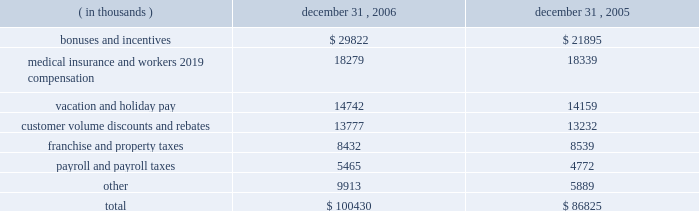Packaging corporation of america notes to consolidated financial statements ( continued ) december 31 , 2006 4 .
Stock-based compensation ( continued ) as of december 31 , 2006 , there was $ 8330000 of total unrecognized compensation costs related to the restricted stock awards .
The company expects to recognize the cost of these stock awards over a weighted-average period of 2.5 years .
Accrued liabilities the components of accrued liabilities are as follows: .
Employee benefit plans and other postretirement benefits in connection with the acquisition from pactiv , pca and pactiv entered into a human resources agreement which , among other items , granted pca employees continued participation in the pactiv pension plan for a period of up to five years following the closing of the acquisition for an agreed upon fee .
Effective january 1 , 2003 , pca adopted a mirror-image pension plan for eligible hourly employees to succeed the pactiv pension plan in which pca hourly employees had participated though december 31 , 2002 .
The pca pension plan for hourly employees recognizes service earned under both the pca plan and the prior pactiv plan .
Benefits earned under the pca plan are reduced by retirement benefits earned under the pactiv plan through december 31 , 2002 .
All assets and liabilities associated with benefits earned through december 31 , 2002 for hourly employees and retirees of pca were retained by the pactiv plan .
Effective may 1 , 2004 , pca adopted a grandfathered pension plan for certain salaried employees who had previously participated in the pactiv pension plan pursuant to the above mentioned human resource agreement .
The benefit formula for the new pca pension plan for salaried employees is comparable to that of the pactiv plan except that the pca plan uses career average base pay in the benefit formula in lieu of final average base pay .
The pca pension plan for salaried employees recognizes service earned under both the pca plan and the prior pactiv plan .
Benefits earned under the pca plan are reduced by retirement benefits earned under the pactiv plan through april 30 , 2004 .
All assets and liabilities associated with benefits earned through april 30 , 2004 for salaried employees and retirees of pca were retained by the pactiv plan .
Pca maintains a supplemental executive retirement plan ( 201cserp 201d ) , which augments pension benefits for eligible executives ( excluding the ceo ) earned under the pca pension plan for salaried employees .
Benefits are determined using the same formula as the pca pension plan but in addition to counting .
What was the percentage change in bonuses and incentives from 2005 to 2006? 
Computations: ((29822 - 21895) / 21895)
Answer: 0.36205. Packaging corporation of america notes to consolidated financial statements ( continued ) december 31 , 2006 4 .
Stock-based compensation ( continued ) as of december 31 , 2006 , there was $ 8330000 of total unrecognized compensation costs related to the restricted stock awards .
The company expects to recognize the cost of these stock awards over a weighted-average period of 2.5 years .
Accrued liabilities the components of accrued liabilities are as follows: .
Employee benefit plans and other postretirement benefits in connection with the acquisition from pactiv , pca and pactiv entered into a human resources agreement which , among other items , granted pca employees continued participation in the pactiv pension plan for a period of up to five years following the closing of the acquisition for an agreed upon fee .
Effective january 1 , 2003 , pca adopted a mirror-image pension plan for eligible hourly employees to succeed the pactiv pension plan in which pca hourly employees had participated though december 31 , 2002 .
The pca pension plan for hourly employees recognizes service earned under both the pca plan and the prior pactiv plan .
Benefits earned under the pca plan are reduced by retirement benefits earned under the pactiv plan through december 31 , 2002 .
All assets and liabilities associated with benefits earned through december 31 , 2002 for hourly employees and retirees of pca were retained by the pactiv plan .
Effective may 1 , 2004 , pca adopted a grandfathered pension plan for certain salaried employees who had previously participated in the pactiv pension plan pursuant to the above mentioned human resource agreement .
The benefit formula for the new pca pension plan for salaried employees is comparable to that of the pactiv plan except that the pca plan uses career average base pay in the benefit formula in lieu of final average base pay .
The pca pension plan for salaried employees recognizes service earned under both the pca plan and the prior pactiv plan .
Benefits earned under the pca plan are reduced by retirement benefits earned under the pactiv plan through april 30 , 2004 .
All assets and liabilities associated with benefits earned through april 30 , 2004 for salaried employees and retirees of pca were retained by the pactiv plan .
Pca maintains a supplemental executive retirement plan ( 201cserp 201d ) , which augments pension benefits for eligible executives ( excluding the ceo ) earned under the pca pension plan for salaried employees .
Benefits are determined using the same formula as the pca pension plan but in addition to counting .
What was the percent of the bonuses and incentives of the total accrued liabilities? 
Rationale: the total bonuses and incentives were 29.7% of the total accrued liabilities
Computations: (29822 / 100430)
Answer: 0.29694. Packaging corporation of america notes to consolidated financial statements ( continued ) december 31 , 2006 4 .
Stock-based compensation ( continued ) as of december 31 , 2006 , there was $ 8330000 of total unrecognized compensation costs related to the restricted stock awards .
The company expects to recognize the cost of these stock awards over a weighted-average period of 2.5 years .
Accrued liabilities the components of accrued liabilities are as follows: .
Employee benefit plans and other postretirement benefits in connection with the acquisition from pactiv , pca and pactiv entered into a human resources agreement which , among other items , granted pca employees continued participation in the pactiv pension plan for a period of up to five years following the closing of the acquisition for an agreed upon fee .
Effective january 1 , 2003 , pca adopted a mirror-image pension plan for eligible hourly employees to succeed the pactiv pension plan in which pca hourly employees had participated though december 31 , 2002 .
The pca pension plan for hourly employees recognizes service earned under both the pca plan and the prior pactiv plan .
Benefits earned under the pca plan are reduced by retirement benefits earned under the pactiv plan through december 31 , 2002 .
All assets and liabilities associated with benefits earned through december 31 , 2002 for hourly employees and retirees of pca were retained by the pactiv plan .
Effective may 1 , 2004 , pca adopted a grandfathered pension plan for certain salaried employees who had previously participated in the pactiv pension plan pursuant to the above mentioned human resource agreement .
The benefit formula for the new pca pension plan for salaried employees is comparable to that of the pactiv plan except that the pca plan uses career average base pay in the benefit formula in lieu of final average base pay .
The pca pension plan for salaried employees recognizes service earned under both the pca plan and the prior pactiv plan .
Benefits earned under the pca plan are reduced by retirement benefits earned under the pactiv plan through april 30 , 2004 .
All assets and liabilities associated with benefits earned through april 30 , 2004 for salaried employees and retirees of pca were retained by the pactiv plan .
Pca maintains a supplemental executive retirement plan ( 201cserp 201d ) , which augments pension benefits for eligible executives ( excluding the ceo ) earned under the pca pension plan for salaried employees .
Benefits are determined using the same formula as the pca pension plan but in addition to counting .
What was the percentage change in payroll and payroll taxes from 2005 to 2006? 
Computations: ((5465 - 4772) / 4772)
Answer: 0.14522. 